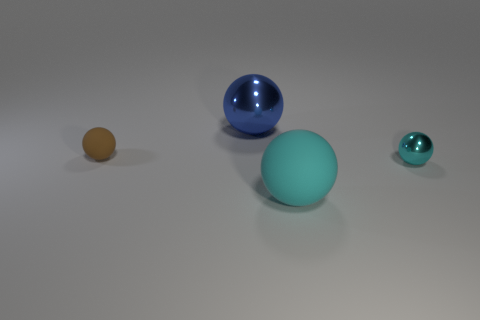What number of other tiny matte objects have the same shape as the blue object?
Make the answer very short. 1. How many things are either large blue shiny spheres or big things behind the large cyan matte ball?
Ensure brevity in your answer.  1. What is the shape of the metallic thing that is the same color as the large matte ball?
Provide a succinct answer. Sphere. How many yellow matte spheres are the same size as the blue shiny ball?
Ensure brevity in your answer.  0. How many blue objects are large metal things or rubber cylinders?
Your answer should be very brief. 1. What shape is the shiny thing that is left of the rubber object in front of the cyan metal object?
Make the answer very short. Sphere. Is there a small sphere of the same color as the large matte sphere?
Keep it short and to the point. Yes. Are there the same number of blue things that are behind the big blue metallic sphere and metal objects that are behind the small cyan ball?
Keep it short and to the point. No. Do the blue shiny thing and the tiny object to the right of the cyan rubber ball have the same shape?
Your answer should be compact. Yes. How many other things are there of the same material as the big cyan sphere?
Provide a succinct answer. 1. 